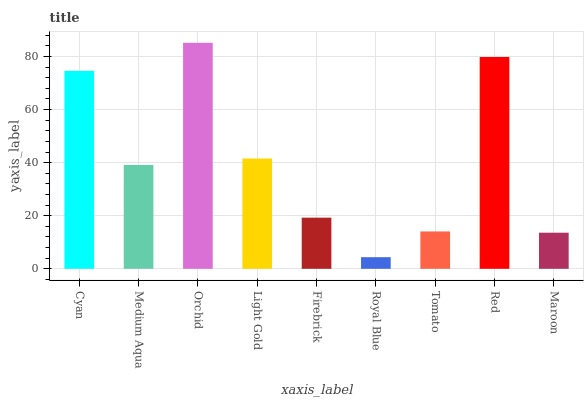Is Royal Blue the minimum?
Answer yes or no. Yes. Is Orchid the maximum?
Answer yes or no. Yes. Is Medium Aqua the minimum?
Answer yes or no. No. Is Medium Aqua the maximum?
Answer yes or no. No. Is Cyan greater than Medium Aqua?
Answer yes or no. Yes. Is Medium Aqua less than Cyan?
Answer yes or no. Yes. Is Medium Aqua greater than Cyan?
Answer yes or no. No. Is Cyan less than Medium Aqua?
Answer yes or no. No. Is Medium Aqua the high median?
Answer yes or no. Yes. Is Medium Aqua the low median?
Answer yes or no. Yes. Is Firebrick the high median?
Answer yes or no. No. Is Maroon the low median?
Answer yes or no. No. 